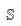<formula> <loc_0><loc_0><loc_500><loc_500>\mathbb { S }</formula> 